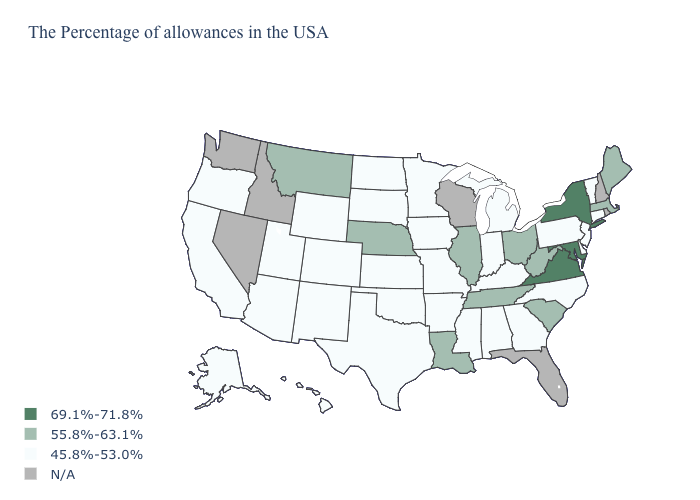Does the map have missing data?
Concise answer only. Yes. What is the value of Louisiana?
Short answer required. 55.8%-63.1%. How many symbols are there in the legend?
Give a very brief answer. 4. Does Montana have the highest value in the West?
Quick response, please. Yes. Which states hav the highest value in the West?
Write a very short answer. Montana. What is the highest value in states that border Delaware?
Concise answer only. 69.1%-71.8%. Which states hav the highest value in the West?
Be succinct. Montana. Name the states that have a value in the range 45.8%-53.0%?
Short answer required. Vermont, Connecticut, New Jersey, Delaware, Pennsylvania, North Carolina, Georgia, Michigan, Kentucky, Indiana, Alabama, Mississippi, Missouri, Arkansas, Minnesota, Iowa, Kansas, Oklahoma, Texas, South Dakota, North Dakota, Wyoming, Colorado, New Mexico, Utah, Arizona, California, Oregon, Alaska, Hawaii. What is the value of New York?
Answer briefly. 69.1%-71.8%. What is the value of Connecticut?
Keep it brief. 45.8%-53.0%. Among the states that border North Carolina , does Virginia have the highest value?
Quick response, please. Yes. Does the map have missing data?
Concise answer only. Yes. What is the value of Montana?
Concise answer only. 55.8%-63.1%. Does the first symbol in the legend represent the smallest category?
Short answer required. No. What is the value of Michigan?
Quick response, please. 45.8%-53.0%. 